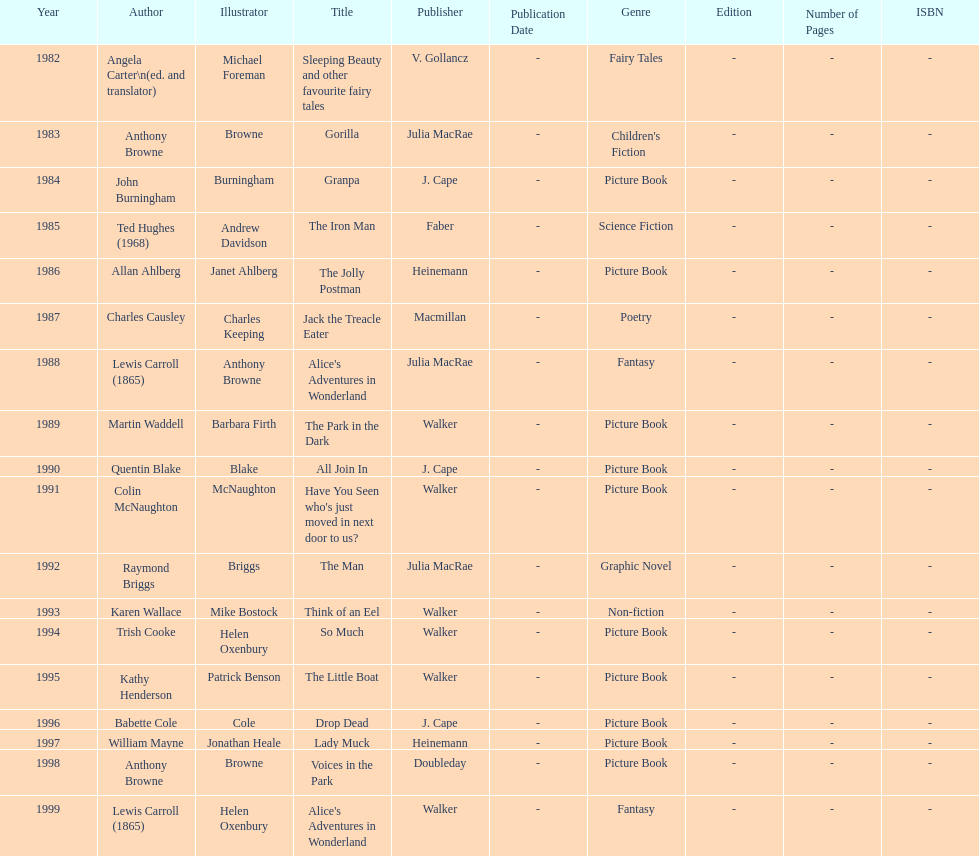Which title was after the year 1991 but before the year 1993? The Man. Would you be able to parse every entry in this table? {'header': ['Year', 'Author', 'Illustrator', 'Title', 'Publisher', 'Publication Date', 'Genre', 'Edition', 'Number of Pages', 'ISBN'], 'rows': [['1982', 'Angela Carter\\n(ed. and translator)', 'Michael Foreman', 'Sleeping Beauty and other favourite fairy tales', 'V. Gollancz', '-', 'Fairy Tales', '-', '-', '-'], ['1983', 'Anthony Browne', 'Browne', 'Gorilla', 'Julia MacRae', '-', "Children's Fiction", '-', '-', '-'], ['1984', 'John Burningham', 'Burningham', 'Granpa', 'J. Cape', '-', 'Picture Book', '-', '-', '-'], ['1985', 'Ted Hughes (1968)', 'Andrew Davidson', 'The Iron Man', 'Faber', '-', 'Science Fiction', '-', '-', '-'], ['1986', 'Allan Ahlberg', 'Janet Ahlberg', 'The Jolly Postman', 'Heinemann', '-', 'Picture Book', '-', '-', '-'], ['1987', 'Charles Causley', 'Charles Keeping', 'Jack the Treacle Eater', 'Macmillan', '-', 'Poetry', '-', '-', '-'], ['1988', 'Lewis Carroll (1865)', 'Anthony Browne', "Alice's Adventures in Wonderland", 'Julia MacRae', '-', 'Fantasy', '-', '-', '-'], ['1989', 'Martin Waddell', 'Barbara Firth', 'The Park in the Dark', 'Walker', '-', 'Picture Book', '-', '-', '-'], ['1990', 'Quentin Blake', 'Blake', 'All Join In', 'J. Cape', '-', 'Picture Book', '-', '-', '-'], ['1991', 'Colin McNaughton', 'McNaughton', "Have You Seen who's just moved in next door to us?", 'Walker', '-', 'Picture Book', '-', '-', '-'], ['1992', 'Raymond Briggs', 'Briggs', 'The Man', 'Julia MacRae', '-', 'Graphic Novel', '-', '-', '-'], ['1993', 'Karen Wallace', 'Mike Bostock', 'Think of an Eel', 'Walker', '-', 'Non-fiction', '-', '-', '-'], ['1994', 'Trish Cooke', 'Helen Oxenbury', 'So Much', 'Walker', '-', 'Picture Book', '-', '-', '-'], ['1995', 'Kathy Henderson', 'Patrick Benson', 'The Little Boat', 'Walker', '-', 'Picture Book', '-', '-', '-'], ['1996', 'Babette Cole', 'Cole', 'Drop Dead', 'J. Cape', '-', 'Picture Book', '-', '-', '-'], ['1997', 'William Mayne', 'Jonathan Heale', 'Lady Muck', 'Heinemann', '-', 'Picture Book', '-', '-', '-'], ['1998', 'Anthony Browne', 'Browne', 'Voices in the Park', 'Doubleday', '-', 'Picture Book', '-', '-', '-'], ['1999', 'Lewis Carroll (1865)', 'Helen Oxenbury', "Alice's Adventures in Wonderland", 'Walker', '-', 'Fantasy', '-', '-', '-']]} 